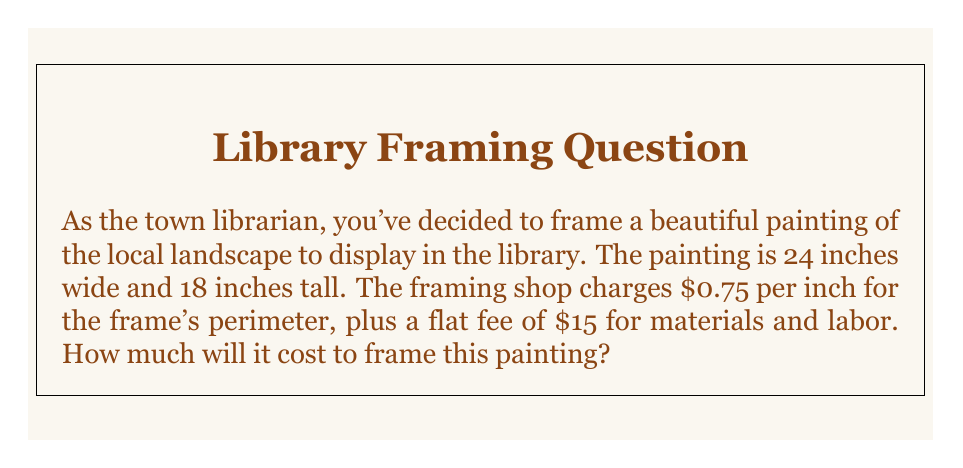Help me with this question. Let's approach this step-by-step:

1. Calculate the perimeter of the painting:
   - Width = 24 inches
   - Height = 18 inches
   - Perimeter = $2 \times (\text{width} + \text{height})$
   - Perimeter = $2 \times (24 + 18) = 2 \times 42 = 84$ inches

2. Calculate the cost for the frame's perimeter:
   - Cost per inch = $0.75
   - Perimeter cost = $84 \times $0.75 = $63

3. Add the flat fee for materials and labor:
   - Flat fee = $15
   - Total cost = Perimeter cost + Flat fee
   - Total cost = $63 + $15 = $78

Therefore, the linear equation for this problem can be expressed as:

$$\text{Total Cost} = 0.75 \times \text{Perimeter} + 15$$

Substituting the perimeter value:

$$\text{Total Cost} = 0.75 \times 84 + 15 = 63 + 15 = 78$$
Answer: $78 